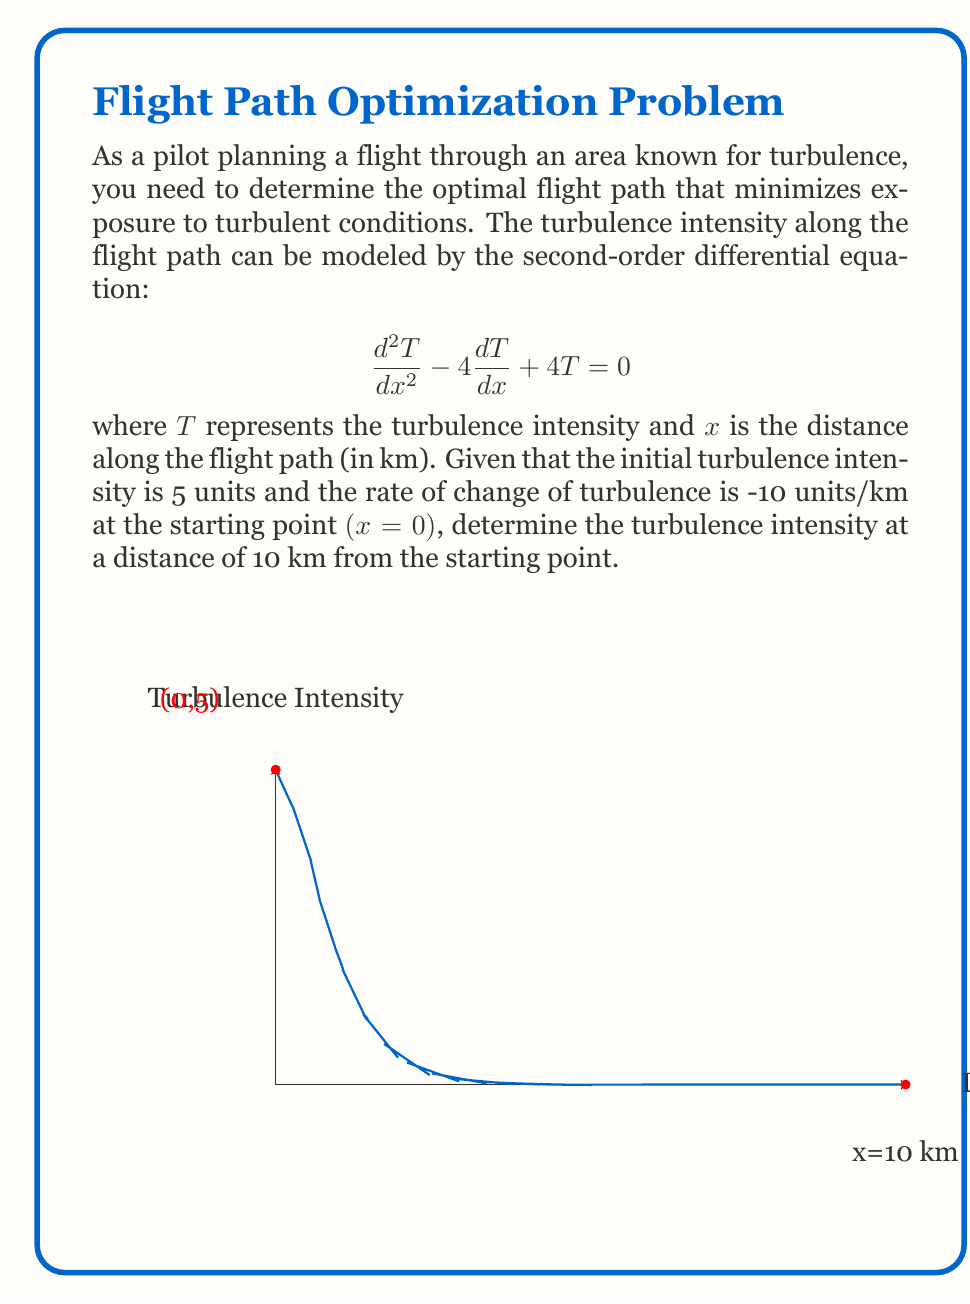Give your solution to this math problem. To solve this problem, we'll follow these steps:

1) The general solution for this second-order linear differential equation is:
   $$T(x) = (C_1 + C_2x)e^{2x}$$

2) We need to find $C_1$ and $C_2$ using the initial conditions:
   At $x=0$, $T(0) = 5$ and $T'(0) = -10$

3) Using $T(0) = 5$:
   $$5 = (C_1 + C_2 \cdot 0)e^{2 \cdot 0} = C_1$$
   So, $C_1 = 5$

4) Now, let's use $T'(0) = -10$:
   $$T'(x) = (C_1 + C_2x)2e^{2x} + C_2e^{2x}$$
   $$T'(0) = (5 + 0)2e^0 + C_2e^0 = 10 + C_2 = -10$$
   $$C_2 = -20$$

5) Now we have our specific solution:
   $$T(x) = (5 - 20x)e^{2x}$$

6) To find the turbulence intensity at $x=10$ km:
   $$T(10) = (5 - 20 \cdot 10)e^{2 \cdot 10}$$
   $$= -195e^{20} \approx -1.78 \times 10^8$$

7) However, since turbulence intensity cannot be negative in reality, we interpret this as effectively zero turbulence at this point.
Answer: 0 (approximately zero turbulence intensity at 10 km) 